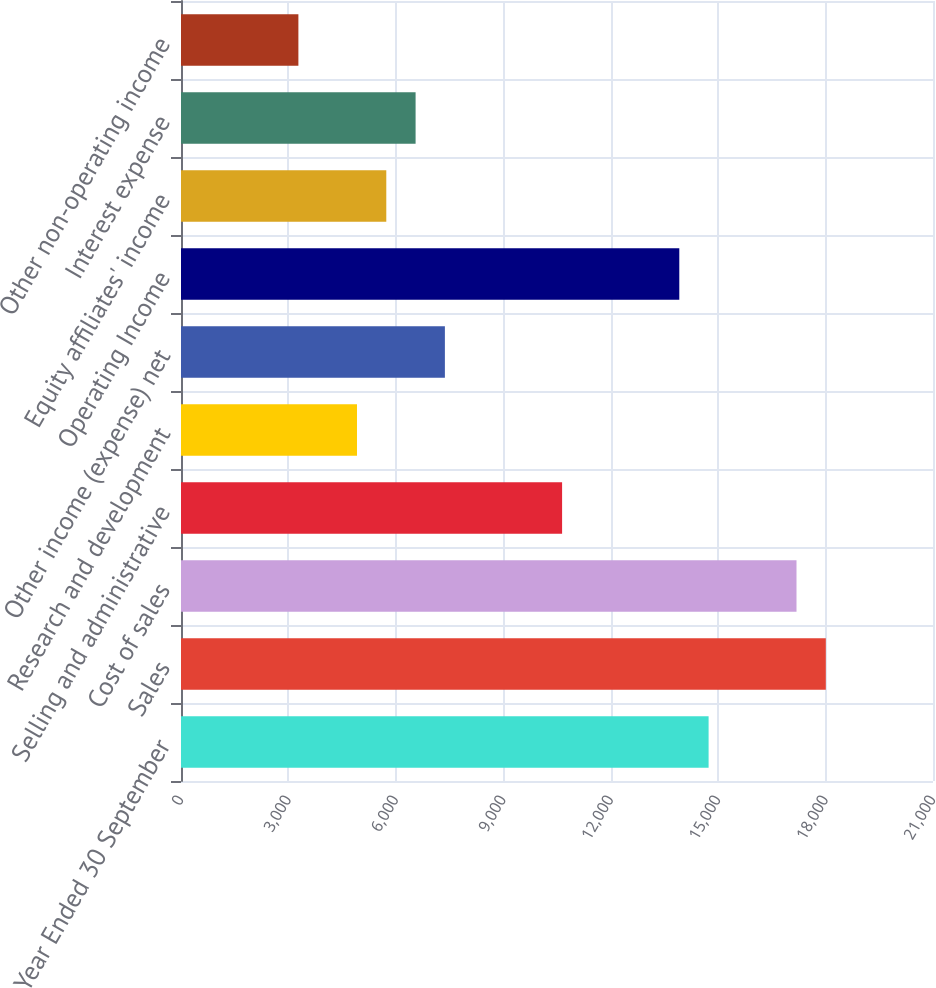Convert chart to OTSL. <chart><loc_0><loc_0><loc_500><loc_500><bar_chart><fcel>Year Ended 30 September<fcel>Sales<fcel>Cost of sales<fcel>Selling and administrative<fcel>Research and development<fcel>Other income (expense) net<fcel>Operating Income<fcel>Equity affiliates' income<fcel>Interest expense<fcel>Other non-operating income<nl><fcel>14733.5<fcel>18006.4<fcel>17188.2<fcel>10642.3<fcel>4914.6<fcel>7369.32<fcel>13915.2<fcel>5732.84<fcel>6551.08<fcel>3278.12<nl></chart> 